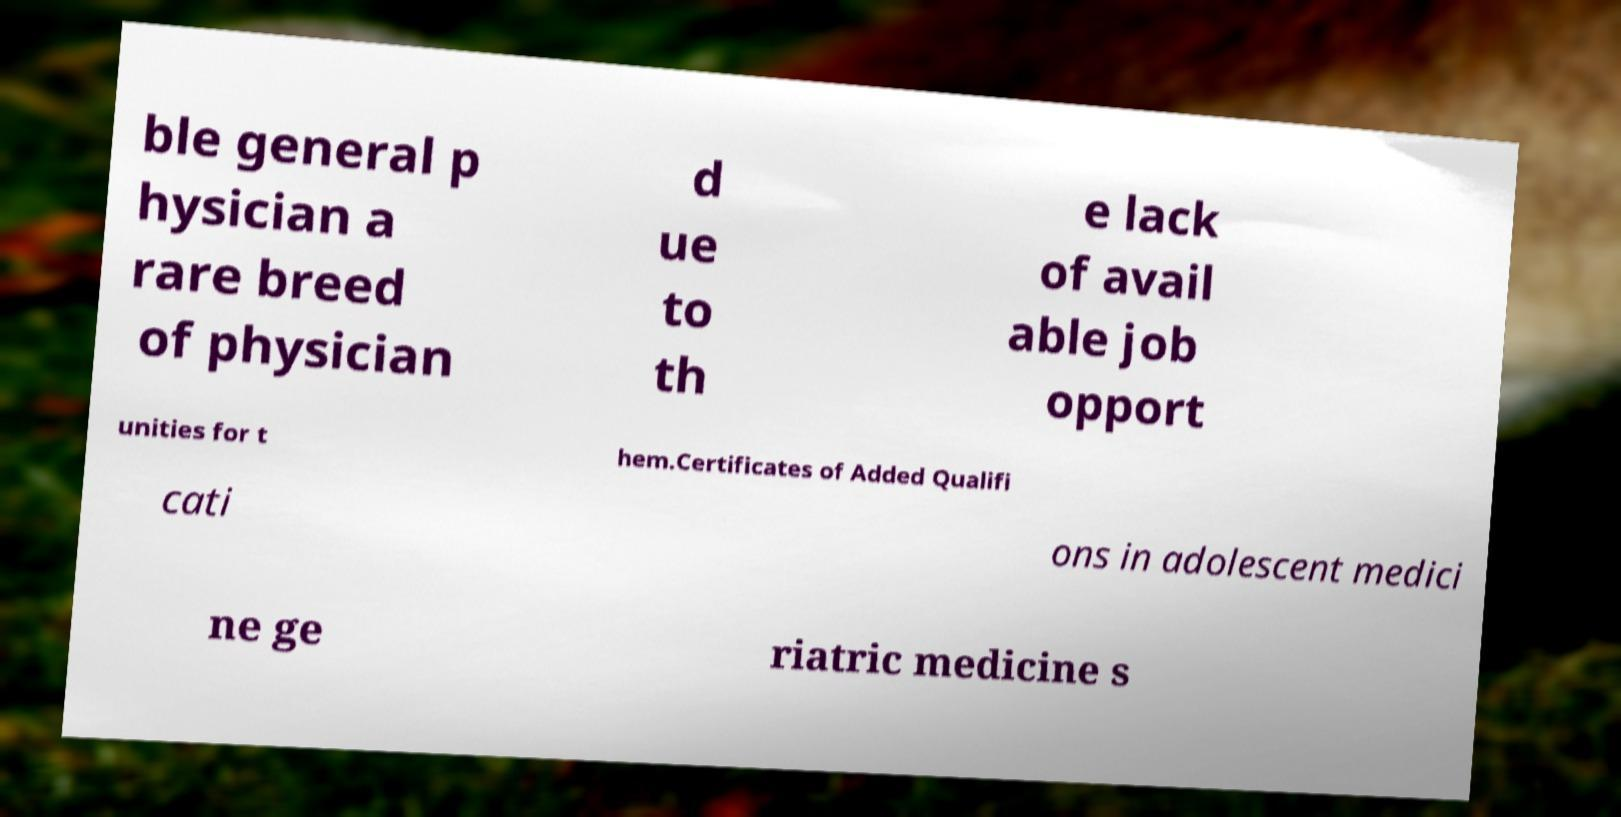There's text embedded in this image that I need extracted. Can you transcribe it verbatim? ble general p hysician a rare breed of physician d ue to th e lack of avail able job opport unities for t hem.Certificates of Added Qualifi cati ons in adolescent medici ne ge riatric medicine s 